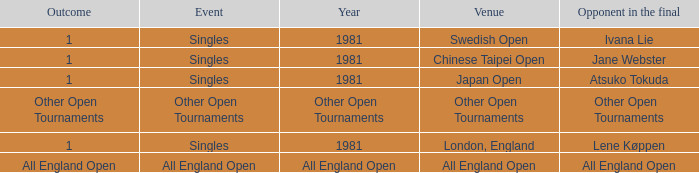What is the Outcome of the Singles Event in London, England? 1.0. Could you parse the entire table? {'header': ['Outcome', 'Event', 'Year', 'Venue', 'Opponent in the final'], 'rows': [['1', 'Singles', '1981', 'Swedish Open', 'Ivana Lie'], ['1', 'Singles', '1981', 'Chinese Taipei Open', 'Jane Webster'], ['1', 'Singles', '1981', 'Japan Open', 'Atsuko Tokuda'], ['Other Open Tournaments', 'Other Open Tournaments', 'Other Open Tournaments', 'Other Open Tournaments', 'Other Open Tournaments'], ['1', 'Singles', '1981', 'London, England', 'Lene Køppen'], ['All England Open', 'All England Open', 'All England Open', 'All England Open', 'All England Open']]} 